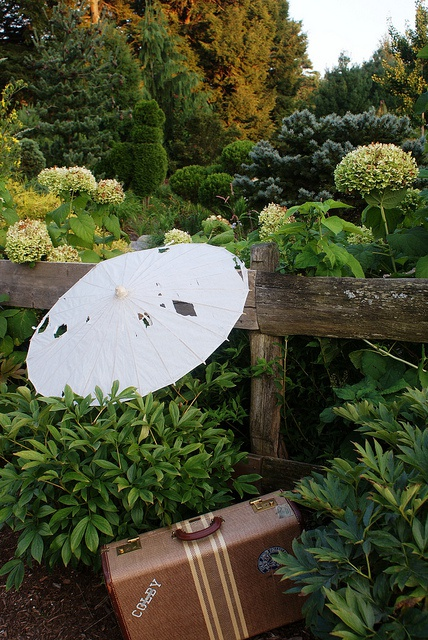Describe the objects in this image and their specific colors. I can see umbrella in lightgray, gray, darkgray, and green tones and suitcase in lightgray, maroon, black, and gray tones in this image. 